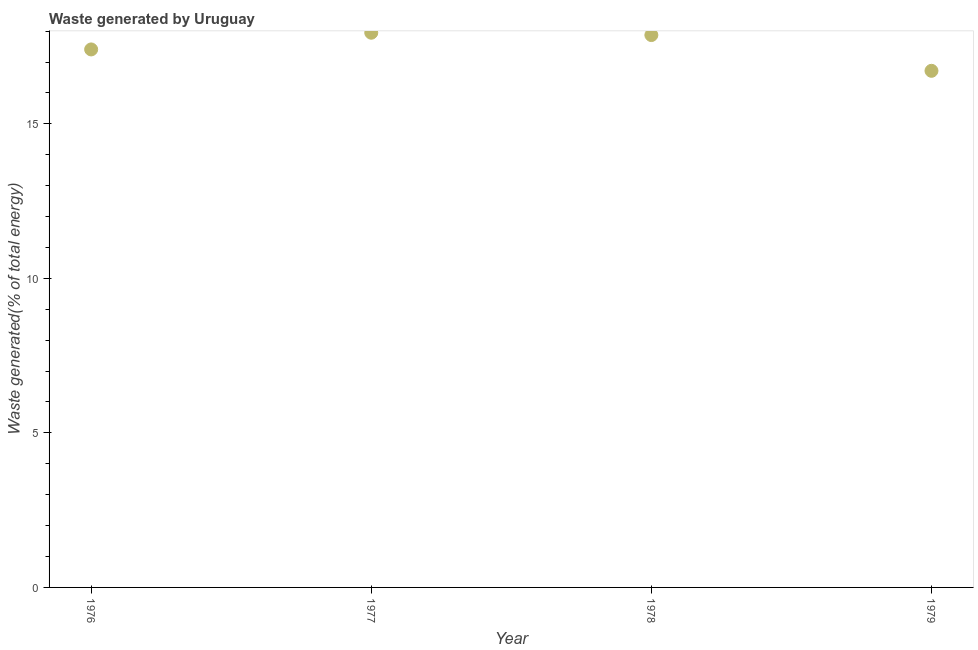What is the amount of waste generated in 1977?
Keep it short and to the point. 17.95. Across all years, what is the maximum amount of waste generated?
Provide a succinct answer. 17.95. Across all years, what is the minimum amount of waste generated?
Your answer should be very brief. 16.72. In which year was the amount of waste generated maximum?
Ensure brevity in your answer.  1977. In which year was the amount of waste generated minimum?
Offer a very short reply. 1979. What is the sum of the amount of waste generated?
Provide a succinct answer. 69.94. What is the difference between the amount of waste generated in 1977 and 1979?
Your response must be concise. 1.23. What is the average amount of waste generated per year?
Your answer should be very brief. 17.49. What is the median amount of waste generated?
Offer a terse response. 17.64. In how many years, is the amount of waste generated greater than 5 %?
Your response must be concise. 4. What is the ratio of the amount of waste generated in 1976 to that in 1979?
Your response must be concise. 1.04. Is the amount of waste generated in 1977 less than that in 1978?
Give a very brief answer. No. What is the difference between the highest and the second highest amount of waste generated?
Offer a terse response. 0.08. Is the sum of the amount of waste generated in 1976 and 1978 greater than the maximum amount of waste generated across all years?
Give a very brief answer. Yes. What is the difference between the highest and the lowest amount of waste generated?
Provide a short and direct response. 1.23. In how many years, is the amount of waste generated greater than the average amount of waste generated taken over all years?
Keep it short and to the point. 2. Are the values on the major ticks of Y-axis written in scientific E-notation?
Give a very brief answer. No. Does the graph contain grids?
Provide a short and direct response. No. What is the title of the graph?
Your response must be concise. Waste generated by Uruguay. What is the label or title of the X-axis?
Your answer should be compact. Year. What is the label or title of the Y-axis?
Give a very brief answer. Waste generated(% of total energy). What is the Waste generated(% of total energy) in 1976?
Make the answer very short. 17.41. What is the Waste generated(% of total energy) in 1977?
Offer a very short reply. 17.95. What is the Waste generated(% of total energy) in 1978?
Provide a short and direct response. 17.87. What is the Waste generated(% of total energy) in 1979?
Your answer should be compact. 16.72. What is the difference between the Waste generated(% of total energy) in 1976 and 1977?
Provide a succinct answer. -0.54. What is the difference between the Waste generated(% of total energy) in 1976 and 1978?
Your answer should be very brief. -0.47. What is the difference between the Waste generated(% of total energy) in 1976 and 1979?
Offer a very short reply. 0.69. What is the difference between the Waste generated(% of total energy) in 1977 and 1978?
Ensure brevity in your answer.  0.08. What is the difference between the Waste generated(% of total energy) in 1977 and 1979?
Offer a terse response. 1.23. What is the difference between the Waste generated(% of total energy) in 1978 and 1979?
Your answer should be compact. 1.16. What is the ratio of the Waste generated(% of total energy) in 1976 to that in 1979?
Offer a terse response. 1.04. What is the ratio of the Waste generated(% of total energy) in 1977 to that in 1979?
Your response must be concise. 1.07. What is the ratio of the Waste generated(% of total energy) in 1978 to that in 1979?
Give a very brief answer. 1.07. 